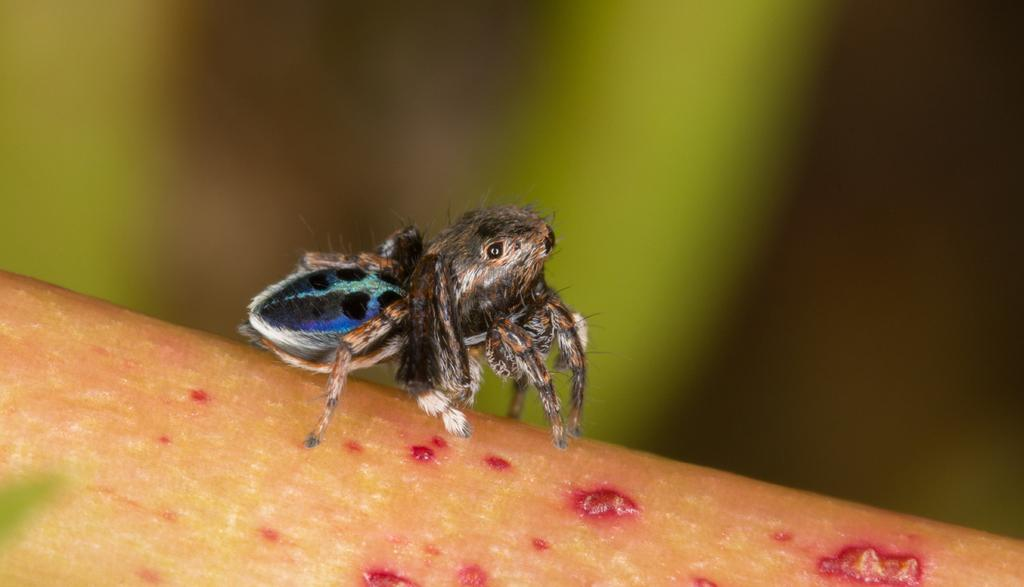What is the main subject of the image? The main subject of the image is a spider. What is the spider doing in the image? The spider is biting on an object in the image. Can you describe the background of the image? The background of the image is blurred. What type of cakes are being served at the statement made by the scarecrow in the image? There is no mention of cakes, statements, or scarecrows in the image; it only features a spider biting on an object with a blurred background. 